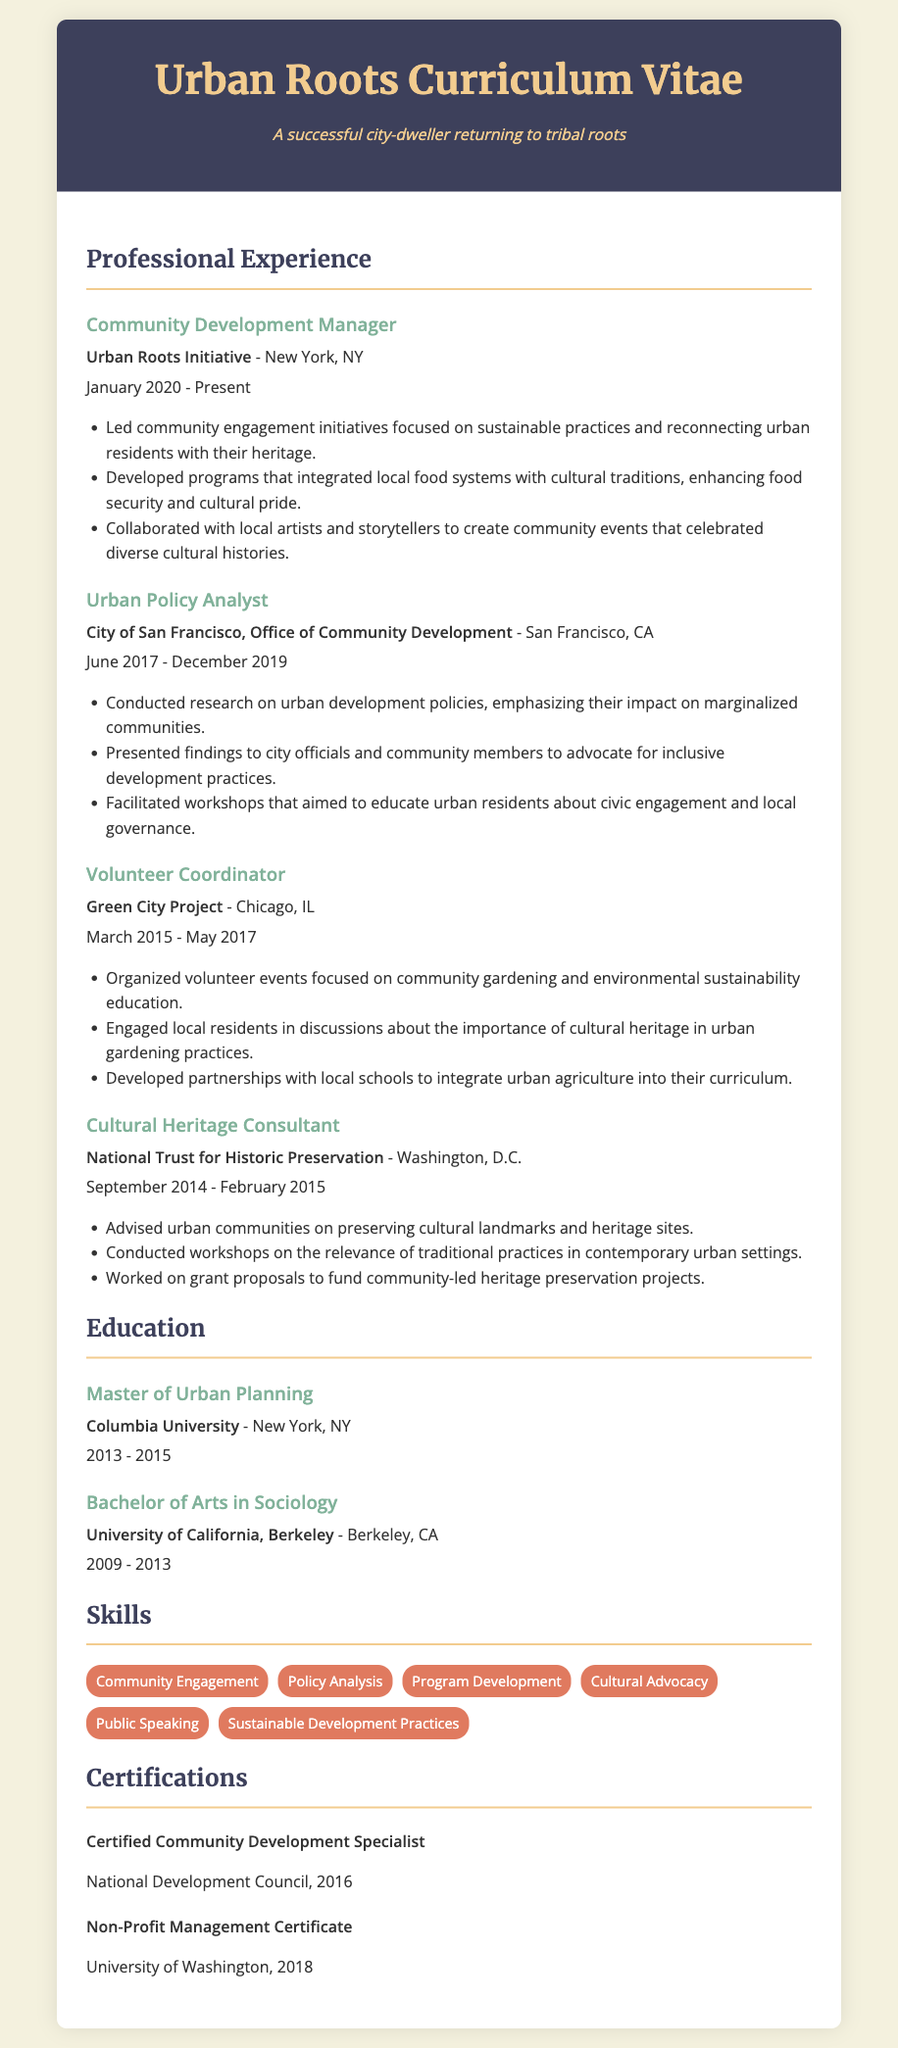What is the current position held? The document lists the current position under "Professional Experience," which is Community Development Manager.
Answer: Community Development Manager Where is the Urban Roots Initiative located? This information is found in the first experience entry, indicating the location of the organization.
Answer: New York, NY What years did the Urban Policy Analyst work? The document specifies the time frame of employment within the second experience entry.
Answer: June 2017 - December 2019 What type of degree was obtained at Columbia University? The education section indicates the degree earned from this institution.
Answer: Master of Urban Planning Which certification is held from the National Development Council? The certifications section lists the certification received from this organization.
Answer: Certified Community Development Specialist What skills are emphasized related to sustainable practices? The skills section includes specific expertise relevant to sustainability which assists in urban community development.
Answer: Sustainable Development Practices How many years of experience are listed in total? By adding the individual experience durations, we calculate the total years of professional involvement.
Answer: Approximately 6 years What project focused on community gardening was mentioned? The document highlights a relevant position that connected volunteer work with community gardening initiatives.
Answer: Green City Project What role did the Cultural Heritage Consultant fulfill? This position's primary focus and responsibilities are detailed in the mentioned experience section.
Answer: Preserving cultural landmarks and heritage sites 